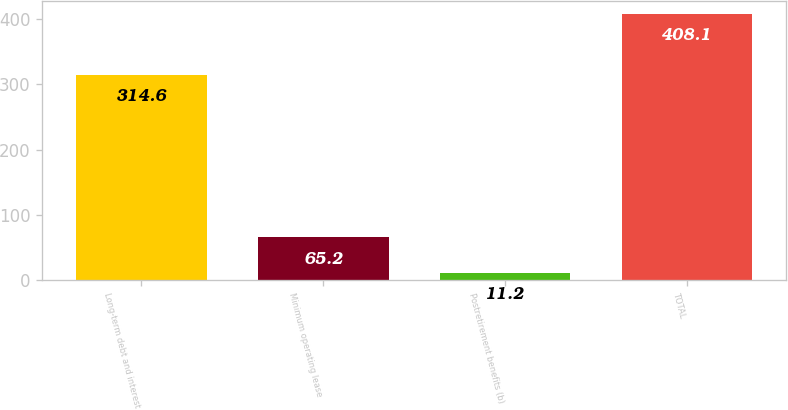<chart> <loc_0><loc_0><loc_500><loc_500><bar_chart><fcel>Long-term debt and interest<fcel>Minimum operating lease<fcel>Postretirement benefits (b)<fcel>TOTAL<nl><fcel>314.6<fcel>65.2<fcel>11.2<fcel>408.1<nl></chart> 